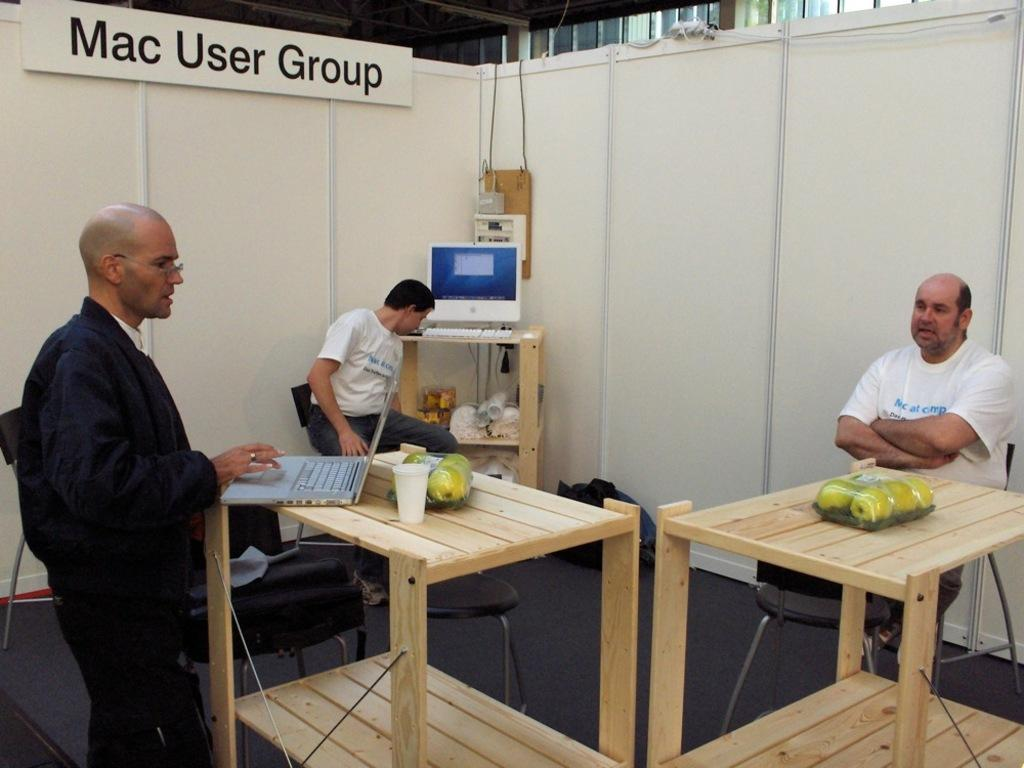<image>
Offer a succinct explanation of the picture presented. A group of three men with a sign Mac User Group 